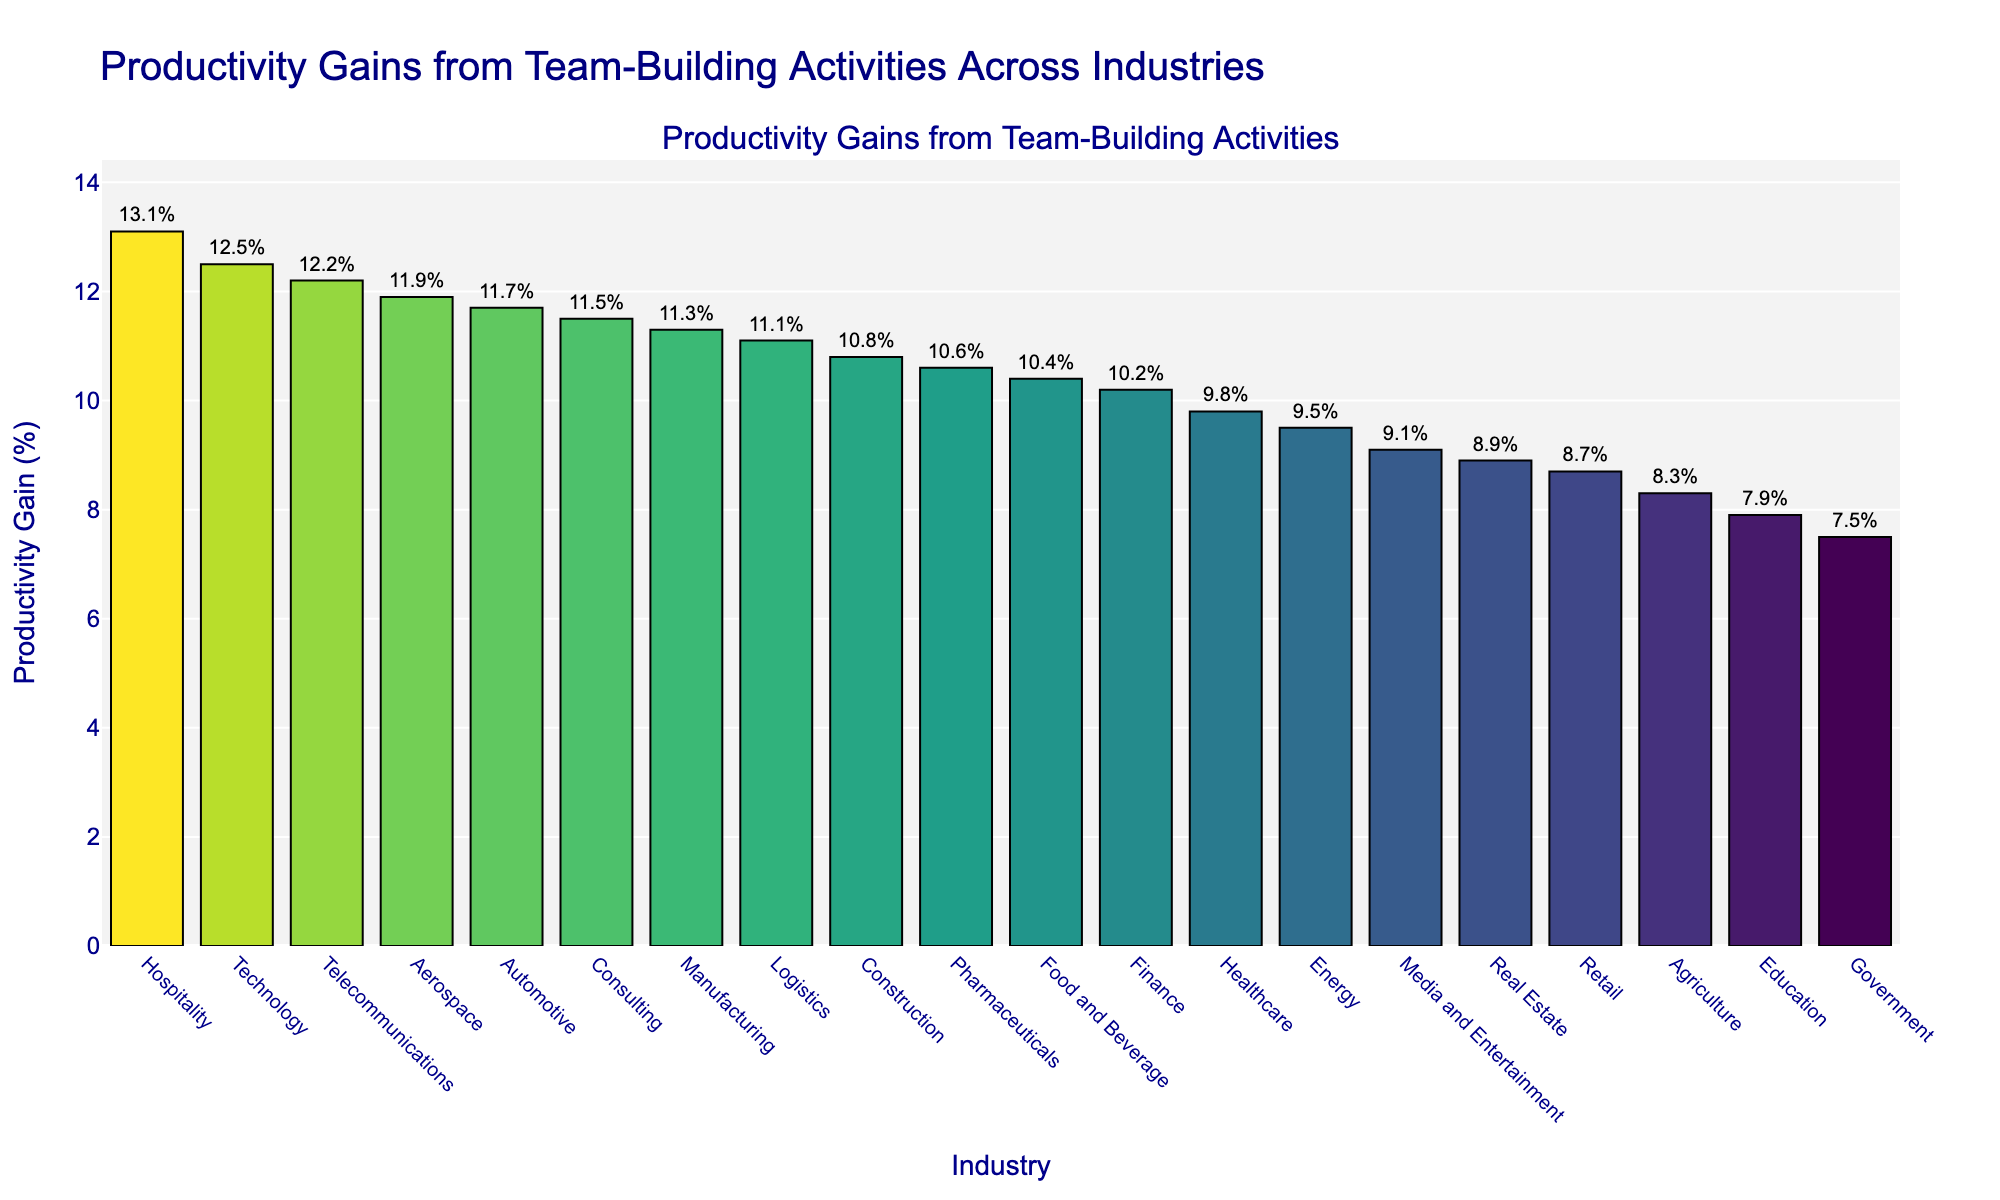What industry has the highest productivity gain from team-building activities? The tallest bar in the figure represents the hospitality industry, indicating the highest productivity gain among all industries shown.
Answer: Hospitality Which three industries show the highest productivity gains? The first three tallest bars in the figure represent the hospitality, technology, and telecommunications industries, indicating the highest productivity gains.
Answer: Hospitality, Technology, Telecommunications What is the combined productivity gain of the technology and healthcare industries? The technology industry has a productivity gain of 12.5% and the healthcare industry has a gain of 9.8%. Adding these two values gives 12.5% + 9.8% = 22.3%.
Answer: 22.3% How much greater is the productivity gain in hospitality compared to retail? The productivity gain in hospitality is 13.1%, and in retail it is 8.7%. Subtracting these two values gives 13.1% - 8.7% = 4.4%.
Answer: 4.4% greater Which industries have a productivity gain less than 10%? The bars below 10% indicate industries with lower productivity gains, which include retail (8.7%), education (7.9%), energy (9.5%), media and entertainment (9.1%), agriculture (8.3%), real estate (8.9%), and government (7.5%).
Answer: Retail, Education, Energy, Media and Entertainment, Agriculture, Real Estate, Government What is the average productivity gain across all industries? Sum all productivity gain percentages and divide by the number of industries. The sum is 205.4%, and there are 20 industries. Therefore, the average is 205.4% / 20 = 10.27%.
Answer: 10.27% Is the productivity gain in pharmaceuticals higher than that in logistics? The figure shows that pharmaceuticals have a gain of 10.6%, while logistics have a gain of 11.1%.
Answer: No How much less is the productivity gain of government compared to aerospace? The productivity gain in government is 7.5%, while in aerospace it is 11.9%. Subtracting these values gives 11.9% - 7.5% = 4.4%.
Answer: 4.4% less Which industry has a productivity gain closest to 10%? The bars around 10% indicate that the finance industry has a productivity gain of 10.2%, which is closest to 10%.
Answer: Finance What visual feature highlights the top 3 industries in the figure? The top 3 industries are highlighted with a translucent gold rectangle around their bars.
Answer: Translucent gold rectangle 